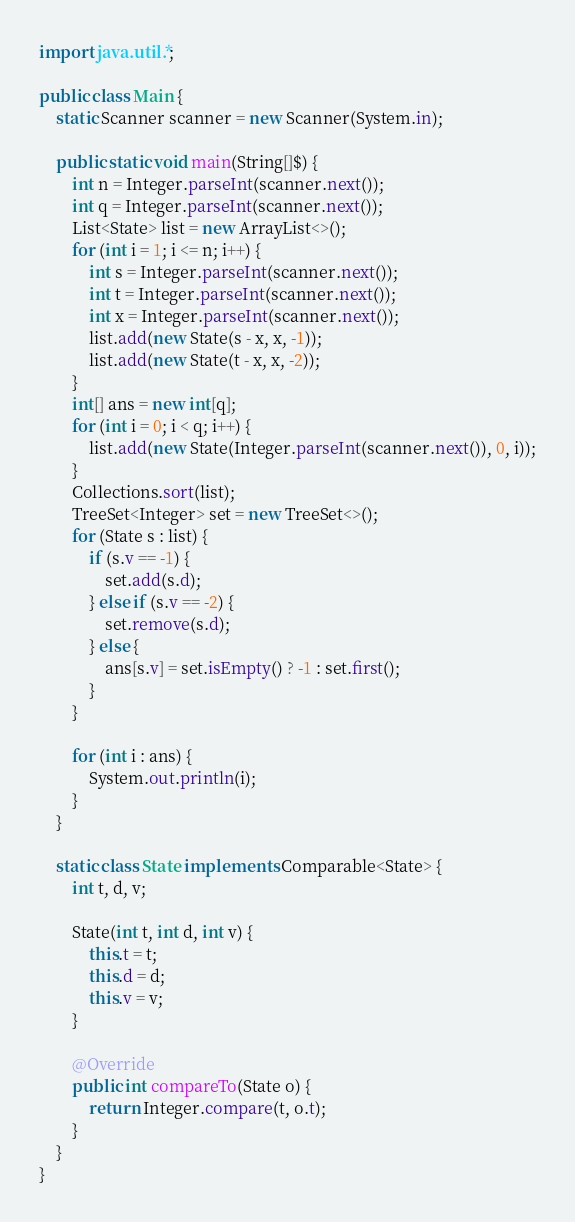<code> <loc_0><loc_0><loc_500><loc_500><_Java_>import java.util.*;

public class Main {
    static Scanner scanner = new Scanner(System.in);

    public static void main(String[]$) {
        int n = Integer.parseInt(scanner.next());
        int q = Integer.parseInt(scanner.next());
        List<State> list = new ArrayList<>();
        for (int i = 1; i <= n; i++) {
            int s = Integer.parseInt(scanner.next());
            int t = Integer.parseInt(scanner.next());
            int x = Integer.parseInt(scanner.next());
            list.add(new State(s - x, x, -1));
            list.add(new State(t - x, x, -2));
        }
        int[] ans = new int[q];
        for (int i = 0; i < q; i++) {
            list.add(new State(Integer.parseInt(scanner.next()), 0, i));
        }
        Collections.sort(list);
        TreeSet<Integer> set = new TreeSet<>();
        for (State s : list) {
            if (s.v == -1) {
                set.add(s.d);
            } else if (s.v == -2) {
                set.remove(s.d);
            } else {
                ans[s.v] = set.isEmpty() ? -1 : set.first();
            }
        }

        for (int i : ans) {
            System.out.println(i);
        }
    }

    static class State implements Comparable<State> {
        int t, d, v;

        State(int t, int d, int v) {
            this.t = t;
            this.d = d;
            this.v = v;
        }

        @Override
        public int compareTo(State o) {
            return Integer.compare(t, o.t);
        }
    }
}</code> 